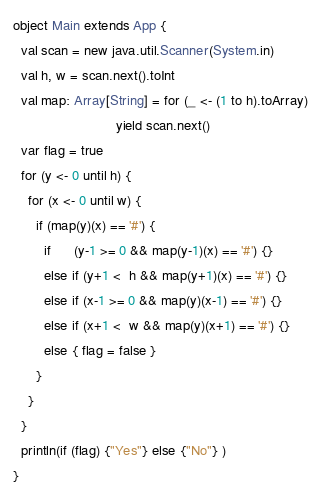Convert code to text. <code><loc_0><loc_0><loc_500><loc_500><_Scala_>object Main extends App {
  val scan = new java.util.Scanner(System.in)
  val h, w = scan.next().toInt
  val map: Array[String] = for (_ <- (1 to h).toArray) 
                           yield scan.next()
  var flag = true
  for (y <- 0 until h) {
    for (x <- 0 until w) {
      if (map(y)(x) == '#') {
        if      (y-1 >= 0 && map(y-1)(x) == '#') {}
        else if (y+1 <  h && map(y+1)(x) == '#') {}
        else if (x-1 >= 0 && map(y)(x-1) == '#') {}
        else if (x+1 <  w && map(y)(x+1) == '#') {}
        else { flag = false }
      }
    }
  }
  println(if (flag) {"Yes"} else {"No"} )
}</code> 